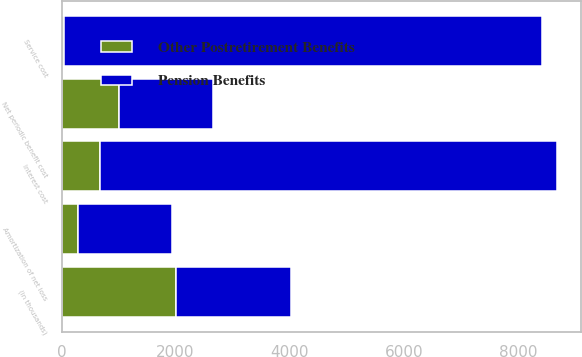Convert chart to OTSL. <chart><loc_0><loc_0><loc_500><loc_500><stacked_bar_chart><ecel><fcel>(in thousands)<fcel>Service cost<fcel>Interest cost<fcel>Amortization of net loss<fcel>Net periodic benefit cost<nl><fcel>Pension Benefits<fcel>2009<fcel>8375<fcel>8003<fcel>1652<fcel>1652<nl><fcel>Other Postretirement Benefits<fcel>2009<fcel>50<fcel>676<fcel>281<fcel>1007<nl></chart> 